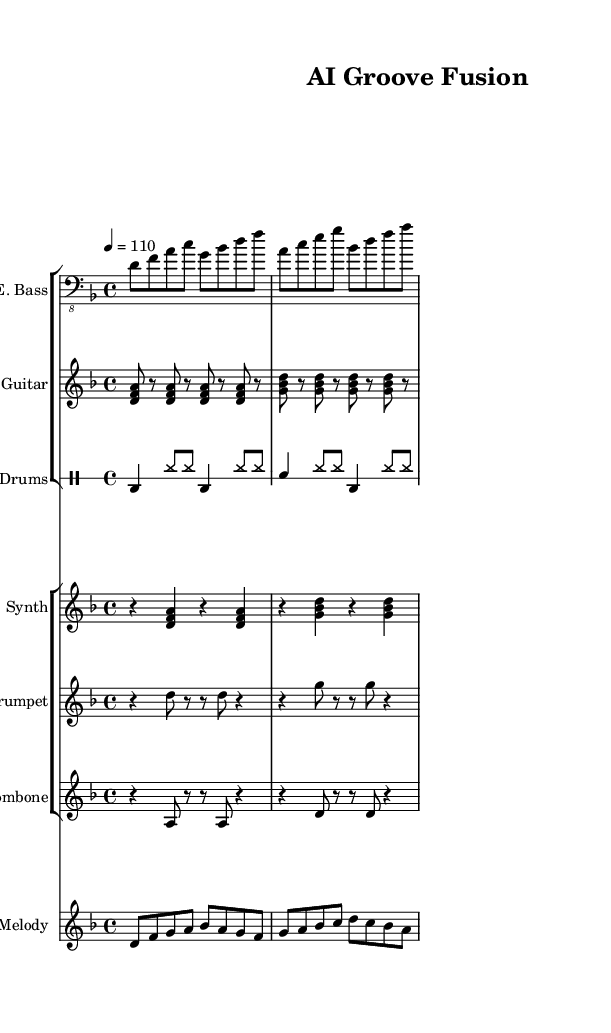What is the key signature of this music? The key signature indicated at the beginning of the score shows one flat, which corresponds to D minor.
Answer: D minor What is the time signature of this music? The time signature is displayed right after the key signature, indicating that there are four beats per measure, which is represented as 4/4.
Answer: 4/4 What is the tempo marking for this piece? The tempo marking shows 4 equals 110, meaning there are 110 quarter note beats in a minute, which is a relatively fast pace.
Answer: 110 How many measures are in the electric bass part? By counting the measures in the electric bass part, I find there are four distinct groups of musical notation that make up four measures.
Answer: 4 Which instruments are composed in the brass section? The brass section consists of a trumpet and a trombone, both indicated in their respective staves.
Answer: Trumpet and Trombone What type of groove is likely present in this piece based on its instrumentation? The presence of a prominent electric bass, funky guitar riffs, and a driving drum pattern suggests that the groove is characteristic of funk music.
Answer: Funk groove What role do the synthesized chords play in this composition? The synthesized chords provide harmonic support and texture to the overall sound, complementing the rhythmic bass lines and melodic lines throughout the piece.
Answer: Harmonic support 